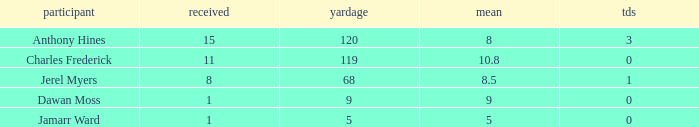What is the highest number of TDs when the Avg is larger than 8.5 and the Rec is less than 1? None. 